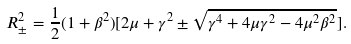<formula> <loc_0><loc_0><loc_500><loc_500>R _ { \pm } ^ { 2 } = { \frac { 1 } { 2 } ( 1 + \beta ^ { 2 } ) } [ 2 \mu + \gamma ^ { 2 } \pm \sqrt { \gamma ^ { 4 } + 4 \mu \gamma ^ { 2 } - 4 \mu ^ { 2 } \beta ^ { 2 } } ] .</formula> 